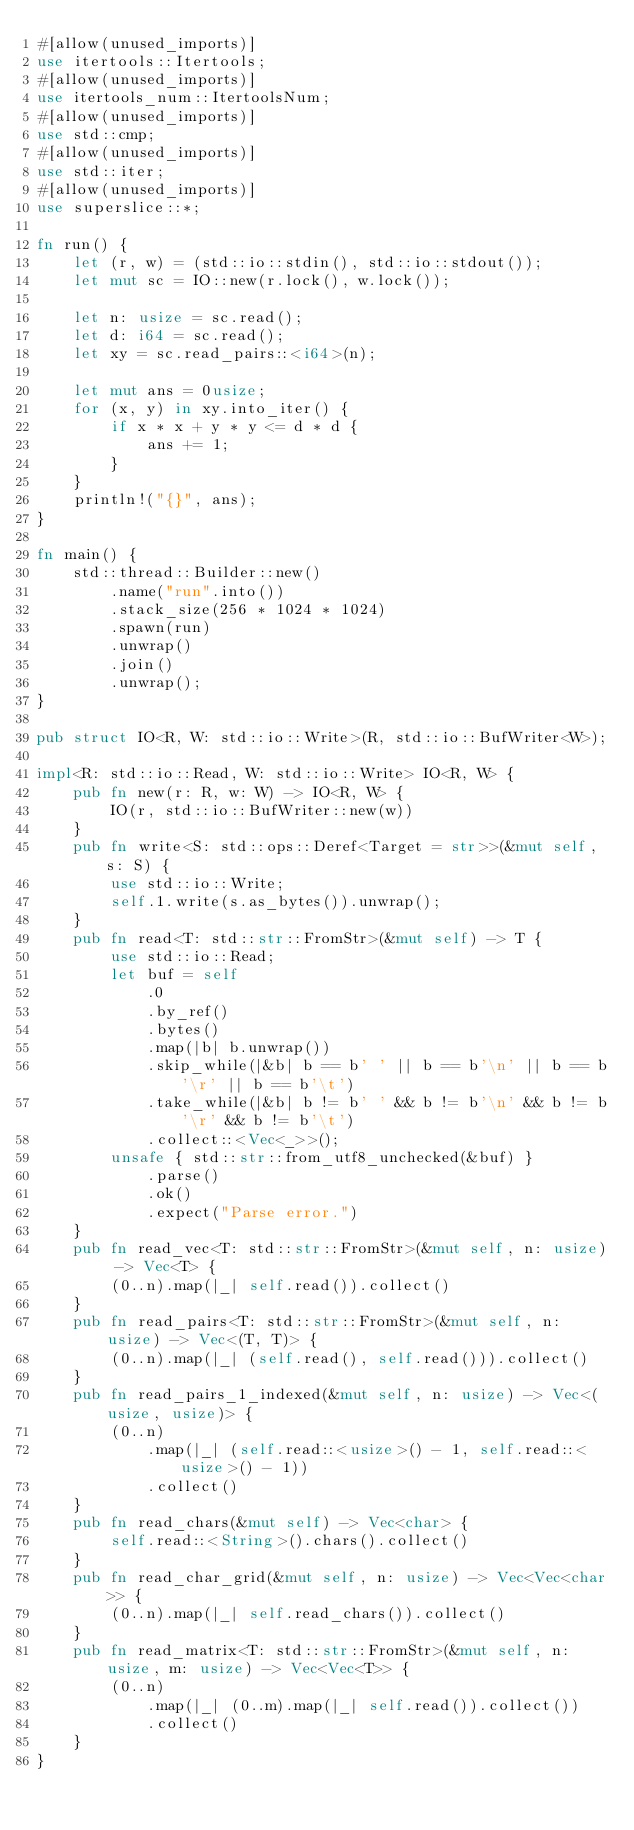<code> <loc_0><loc_0><loc_500><loc_500><_Rust_>#[allow(unused_imports)]
use itertools::Itertools;
#[allow(unused_imports)]
use itertools_num::ItertoolsNum;
#[allow(unused_imports)]
use std::cmp;
#[allow(unused_imports)]
use std::iter;
#[allow(unused_imports)]
use superslice::*;

fn run() {
    let (r, w) = (std::io::stdin(), std::io::stdout());
    let mut sc = IO::new(r.lock(), w.lock());

    let n: usize = sc.read();
    let d: i64 = sc.read();
    let xy = sc.read_pairs::<i64>(n);

    let mut ans = 0usize;
    for (x, y) in xy.into_iter() {
        if x * x + y * y <= d * d {
            ans += 1;
        }
    }
    println!("{}", ans);
}

fn main() {
    std::thread::Builder::new()
        .name("run".into())
        .stack_size(256 * 1024 * 1024)
        .spawn(run)
        .unwrap()
        .join()
        .unwrap();
}

pub struct IO<R, W: std::io::Write>(R, std::io::BufWriter<W>);

impl<R: std::io::Read, W: std::io::Write> IO<R, W> {
    pub fn new(r: R, w: W) -> IO<R, W> {
        IO(r, std::io::BufWriter::new(w))
    }
    pub fn write<S: std::ops::Deref<Target = str>>(&mut self, s: S) {
        use std::io::Write;
        self.1.write(s.as_bytes()).unwrap();
    }
    pub fn read<T: std::str::FromStr>(&mut self) -> T {
        use std::io::Read;
        let buf = self
            .0
            .by_ref()
            .bytes()
            .map(|b| b.unwrap())
            .skip_while(|&b| b == b' ' || b == b'\n' || b == b'\r' || b == b'\t')
            .take_while(|&b| b != b' ' && b != b'\n' && b != b'\r' && b != b'\t')
            .collect::<Vec<_>>();
        unsafe { std::str::from_utf8_unchecked(&buf) }
            .parse()
            .ok()
            .expect("Parse error.")
    }
    pub fn read_vec<T: std::str::FromStr>(&mut self, n: usize) -> Vec<T> {
        (0..n).map(|_| self.read()).collect()
    }
    pub fn read_pairs<T: std::str::FromStr>(&mut self, n: usize) -> Vec<(T, T)> {
        (0..n).map(|_| (self.read(), self.read())).collect()
    }
    pub fn read_pairs_1_indexed(&mut self, n: usize) -> Vec<(usize, usize)> {
        (0..n)
            .map(|_| (self.read::<usize>() - 1, self.read::<usize>() - 1))
            .collect()
    }
    pub fn read_chars(&mut self) -> Vec<char> {
        self.read::<String>().chars().collect()
    }
    pub fn read_char_grid(&mut self, n: usize) -> Vec<Vec<char>> {
        (0..n).map(|_| self.read_chars()).collect()
    }
    pub fn read_matrix<T: std::str::FromStr>(&mut self, n: usize, m: usize) -> Vec<Vec<T>> {
        (0..n)
            .map(|_| (0..m).map(|_| self.read()).collect())
            .collect()
    }
}
</code> 